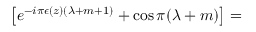<formula> <loc_0><loc_0><loc_500><loc_500>\left [ e ^ { - i \pi \epsilon ( z ) ( \lambda + m + 1 ) } + \cos \pi ( \lambda + m ) \right ] =</formula> 